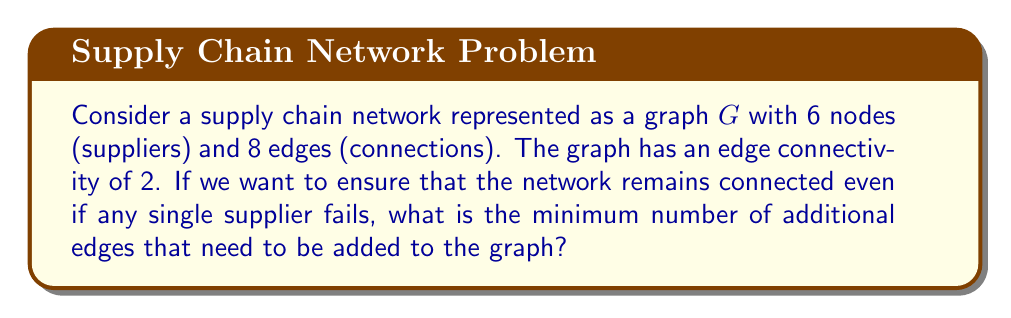Teach me how to tackle this problem. To solve this problem, we need to understand the concept of edge connectivity in graph theory and its implications for supply chain robustness.

1. Edge connectivity:
   The edge connectivity of a graph, denoted as $\lambda(G)$, is the minimum number of edges that need to be removed to disconnect the graph.

2. Current state:
   Given: $\lambda(G) = 2$
   This means the graph can be disconnected by removing 2 edges.

3. Goal:
   We want to ensure the graph remains connected even if any single supplier (node) fails.
   This is equivalent to having a graph with edge connectivity of at least 3.

4. Menger's theorem:
   Menger's theorem states that the edge connectivity of a graph is equal to the minimum number of edge-disjoint paths between any pair of vertices.

5. Minimum number of additional edges:
   To increase the edge connectivity from 2 to 3, we need to add at least one more edge-disjoint path between the pair of vertices that currently have only 2 edge-disjoint paths.

6. Calculation:
   Minimum number of additional edges = Target edge connectivity - Current edge connectivity
   $$ \text{Additional edges} = 3 - 2 = 1 $$

Therefore, we need to add at least 1 edge to the graph to ensure it remains connected even if any single supplier fails.
Answer: 1 edge 